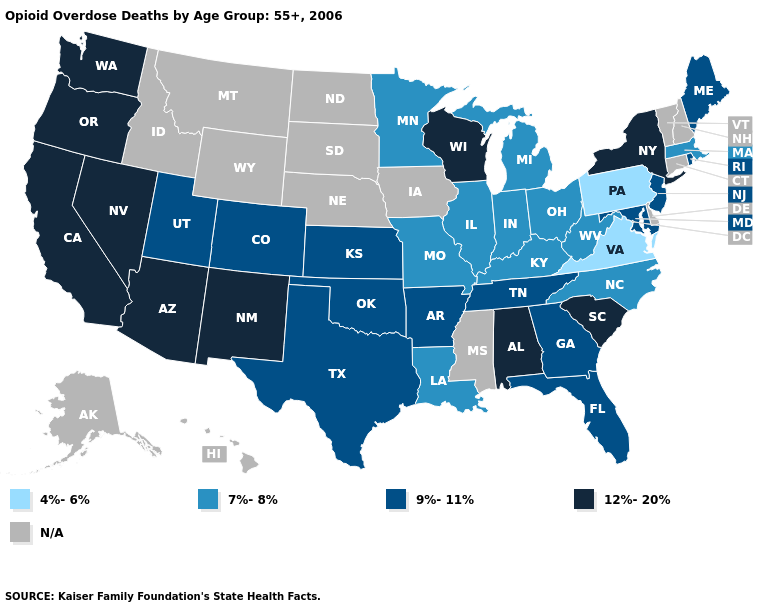What is the value of New Jersey?
Keep it brief. 9%-11%. Does New York have the highest value in the Northeast?
Be succinct. Yes. Name the states that have a value in the range 12%-20%?
Short answer required. Alabama, Arizona, California, Nevada, New Mexico, New York, Oregon, South Carolina, Washington, Wisconsin. What is the value of South Dakota?
Concise answer only. N/A. What is the lowest value in states that border Idaho?
Concise answer only. 9%-11%. Among the states that border Nebraska , which have the lowest value?
Write a very short answer. Missouri. Does Virginia have the lowest value in the USA?
Be succinct. Yes. Does Texas have the lowest value in the USA?
Answer briefly. No. What is the value of New York?
Short answer required. 12%-20%. What is the lowest value in states that border New Mexico?
Keep it brief. 9%-11%. Among the states that border Maryland , does West Virginia have the highest value?
Give a very brief answer. Yes. What is the value of Wisconsin?
Concise answer only. 12%-20%. Is the legend a continuous bar?
Concise answer only. No. Name the states that have a value in the range 9%-11%?
Write a very short answer. Arkansas, Colorado, Florida, Georgia, Kansas, Maine, Maryland, New Jersey, Oklahoma, Rhode Island, Tennessee, Texas, Utah. Among the states that border Washington , which have the lowest value?
Keep it brief. Oregon. 